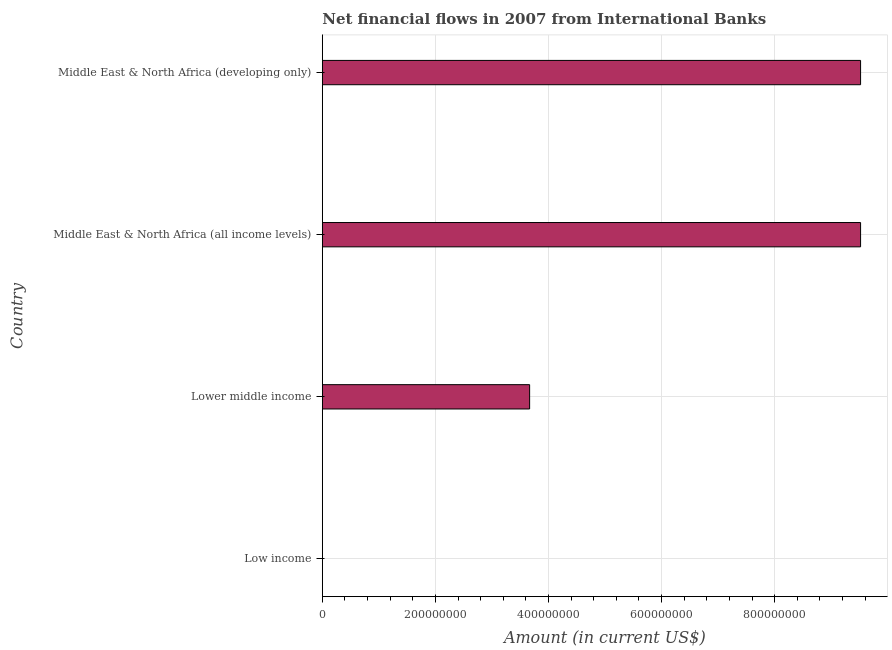What is the title of the graph?
Your response must be concise. Net financial flows in 2007 from International Banks. What is the label or title of the X-axis?
Provide a succinct answer. Amount (in current US$). What is the label or title of the Y-axis?
Offer a very short reply. Country. What is the net financial flows from ibrd in Low income?
Ensure brevity in your answer.  0. Across all countries, what is the maximum net financial flows from ibrd?
Your answer should be very brief. 9.52e+08. Across all countries, what is the minimum net financial flows from ibrd?
Your answer should be compact. 0. In which country was the net financial flows from ibrd maximum?
Provide a short and direct response. Middle East & North Africa (all income levels). What is the sum of the net financial flows from ibrd?
Keep it short and to the point. 2.27e+09. What is the difference between the net financial flows from ibrd in Lower middle income and Middle East & North Africa (developing only)?
Your answer should be very brief. -5.85e+08. What is the average net financial flows from ibrd per country?
Keep it short and to the point. 5.68e+08. What is the median net financial flows from ibrd?
Give a very brief answer. 6.59e+08. In how many countries, is the net financial flows from ibrd greater than 840000000 US$?
Provide a succinct answer. 2. What is the ratio of the net financial flows from ibrd in Lower middle income to that in Middle East & North Africa (developing only)?
Give a very brief answer. 0.39. Is the net financial flows from ibrd in Lower middle income less than that in Middle East & North Africa (developing only)?
Your response must be concise. Yes. What is the difference between the highest and the lowest net financial flows from ibrd?
Offer a terse response. 9.52e+08. How many bars are there?
Keep it short and to the point. 3. Are all the bars in the graph horizontal?
Your response must be concise. Yes. What is the difference between two consecutive major ticks on the X-axis?
Offer a terse response. 2.00e+08. What is the Amount (in current US$) of Low income?
Provide a short and direct response. 0. What is the Amount (in current US$) of Lower middle income?
Provide a succinct answer. 3.67e+08. What is the Amount (in current US$) of Middle East & North Africa (all income levels)?
Provide a short and direct response. 9.52e+08. What is the Amount (in current US$) in Middle East & North Africa (developing only)?
Your answer should be compact. 9.52e+08. What is the difference between the Amount (in current US$) in Lower middle income and Middle East & North Africa (all income levels)?
Your answer should be compact. -5.85e+08. What is the difference between the Amount (in current US$) in Lower middle income and Middle East & North Africa (developing only)?
Give a very brief answer. -5.85e+08. What is the ratio of the Amount (in current US$) in Lower middle income to that in Middle East & North Africa (all income levels)?
Keep it short and to the point. 0.39. What is the ratio of the Amount (in current US$) in Lower middle income to that in Middle East & North Africa (developing only)?
Your answer should be very brief. 0.39. 